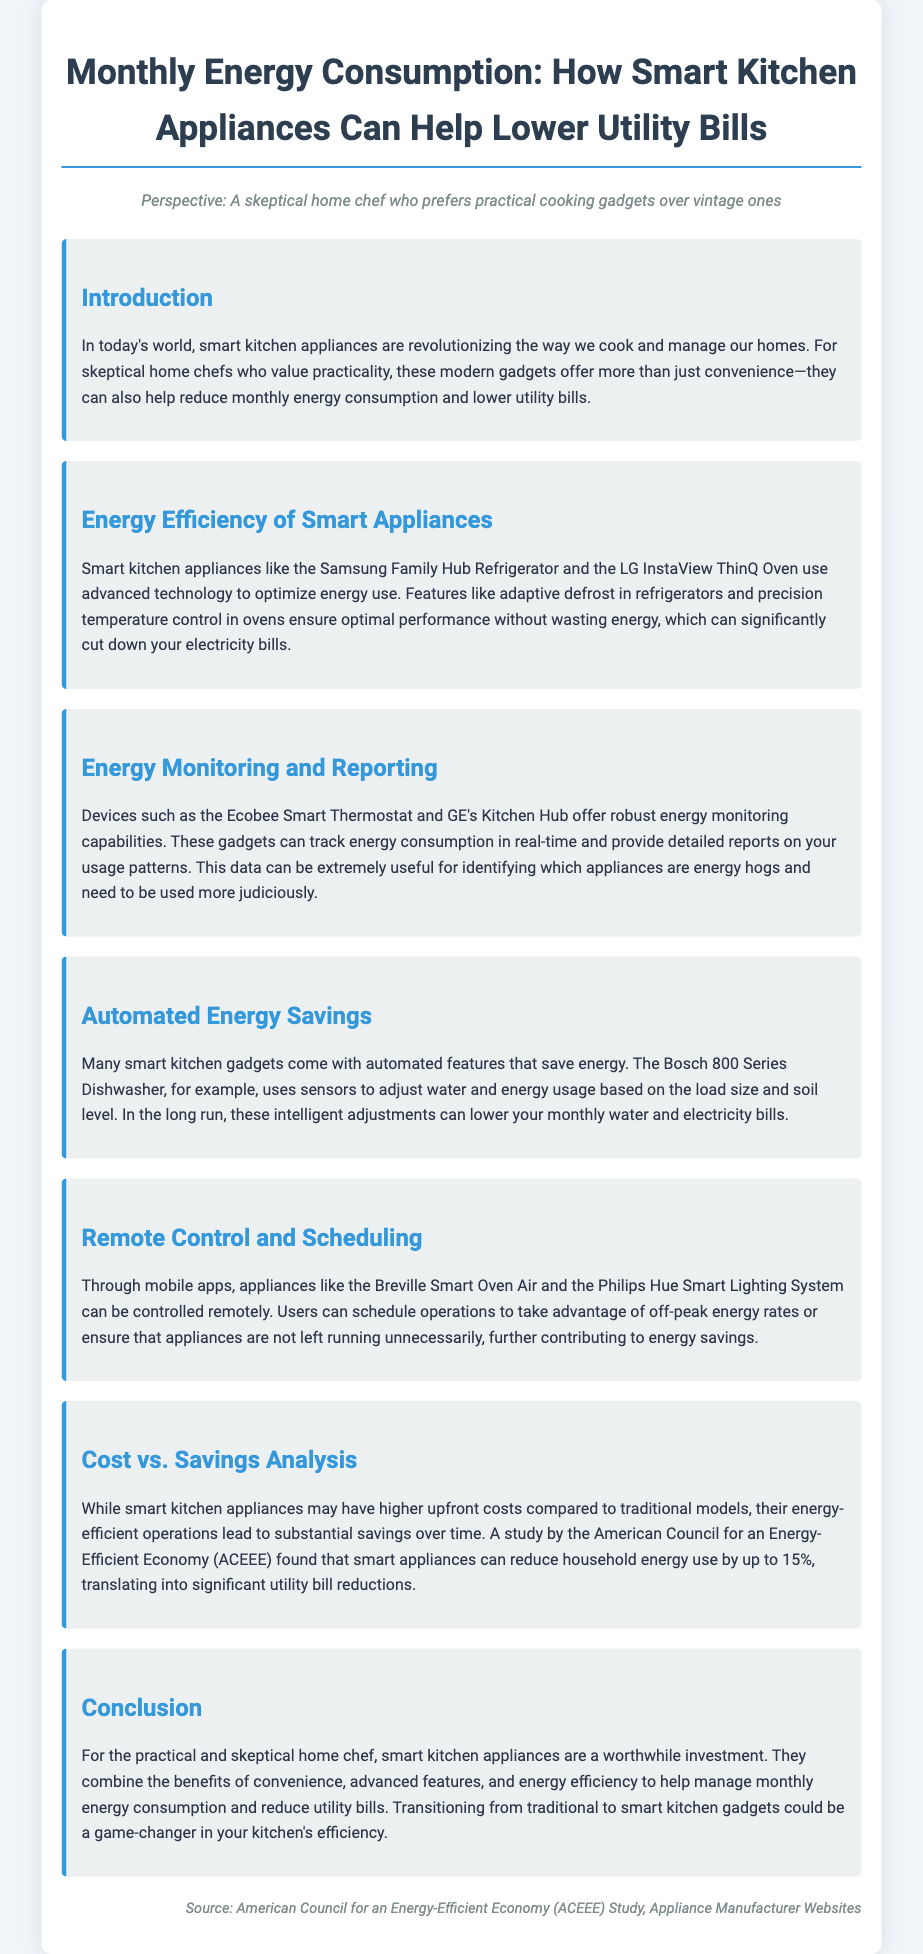What is the main benefit of smart kitchen appliances? The main benefit is reducing monthly energy consumption and lowering utility bills.
Answer: Reducing monthly energy consumption and lowering utility bills What specific feature helps the Samsung Family Hub Refrigerator optimize energy use? The refrigerator uses adaptive defrost technology to optimize energy use.
Answer: Adaptive defrost How much can smart appliances reduce household energy use, according to the ACEEE study? The study found that smart appliances can reduce household energy use by up to 15%.
Answer: 15% Which appliance uses sensors to adjust water and energy usage? The Bosch 800 Series Dishwasher uses sensors for adjustments.
Answer: Bosch 800 Series Dishwasher What can the Ecobee Smart Thermostat track? The Ecobee Smart Thermostat can track energy consumption in real-time.
Answer: Energy consumption Why might smart appliances lead to substantial savings? Their energy-efficient operations lead to substantial savings over time.
Answer: Energy-efficient operations What type of analysis is mentioned in the document? A cost vs. savings analysis is mentioned.
Answer: Cost vs. savings analysis What is a key feature of the Breville Smart Oven Air? It can be controlled remotely through mobile apps.
Answer: Remote control through mobile apps 